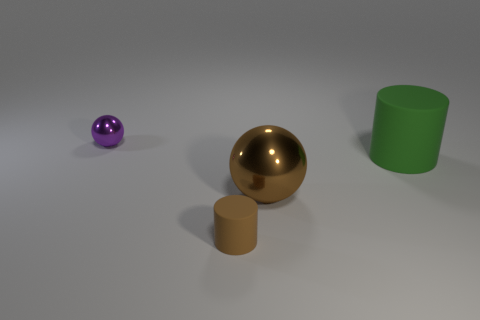Add 3 rubber cylinders. How many objects exist? 7 Add 4 large green cylinders. How many large green cylinders are left? 5 Add 1 small purple balls. How many small purple balls exist? 2 Subtract 0 yellow cubes. How many objects are left? 4 Subtract all red cubes. Subtract all brown rubber cylinders. How many objects are left? 3 